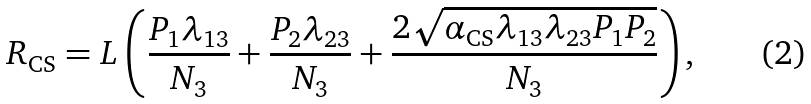Convert formula to latex. <formula><loc_0><loc_0><loc_500><loc_500>R _ { \text {CS} } = L \left ( \frac { P _ { 1 } \lambda _ { 1 3 } } { N _ { 3 } } + \frac { P _ { 2 } \lambda _ { 2 3 } } { N _ { 3 } } + \frac { 2 \sqrt { \alpha _ { \text {CS} } \lambda _ { 1 3 } \lambda _ { 2 3 } P _ { 1 } P _ { 2 } } } { N _ { 3 } } \right ) ,</formula> 